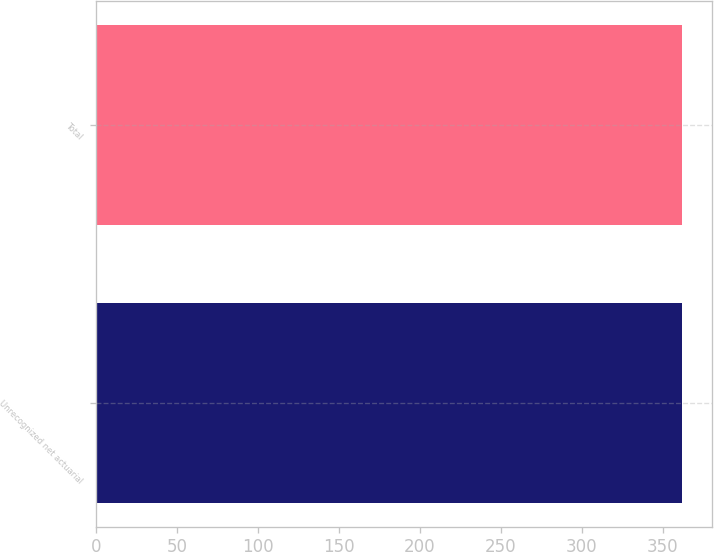Convert chart. <chart><loc_0><loc_0><loc_500><loc_500><bar_chart><fcel>Unrecognized net actuarial<fcel>Total<nl><fcel>362.1<fcel>362.2<nl></chart> 